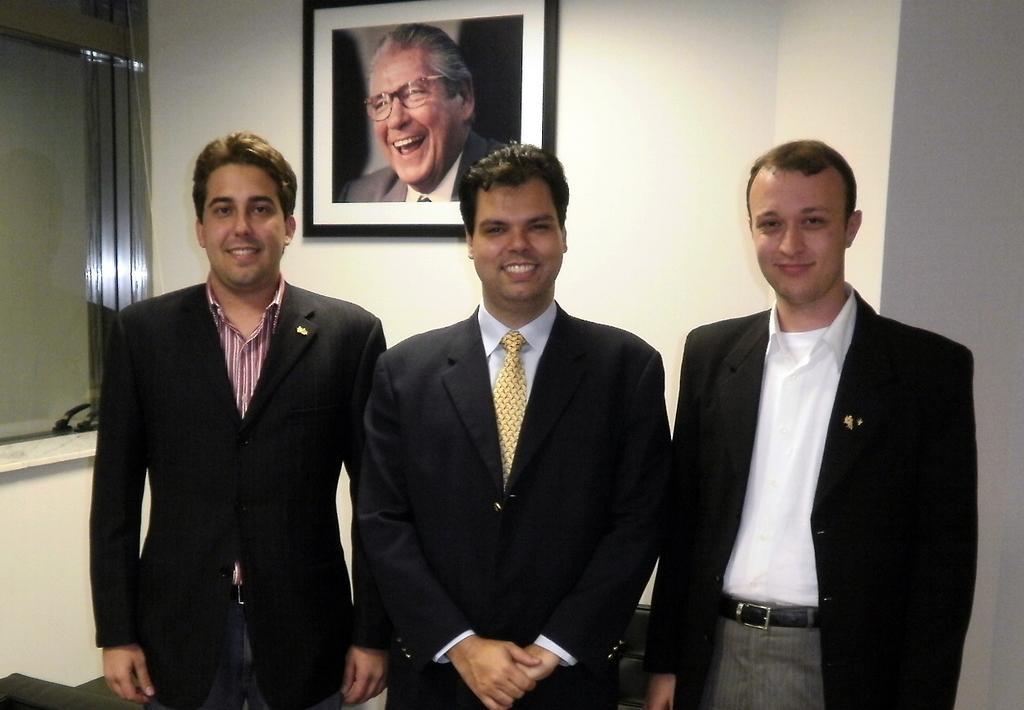In one or two sentences, can you explain what this image depicts? In the picture we can see three men are standing, they are wearing blazers with shirts and one man is also wearing a tie and in the background we can see a wall and a photo frame with a person image laughing in it and besides we can see a glass window. 